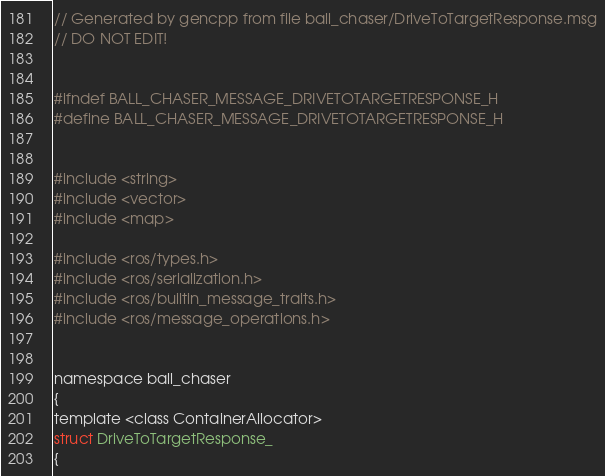<code> <loc_0><loc_0><loc_500><loc_500><_C_>// Generated by gencpp from file ball_chaser/DriveToTargetResponse.msg
// DO NOT EDIT!


#ifndef BALL_CHASER_MESSAGE_DRIVETOTARGETRESPONSE_H
#define BALL_CHASER_MESSAGE_DRIVETOTARGETRESPONSE_H


#include <string>
#include <vector>
#include <map>

#include <ros/types.h>
#include <ros/serialization.h>
#include <ros/builtin_message_traits.h>
#include <ros/message_operations.h>


namespace ball_chaser
{
template <class ContainerAllocator>
struct DriveToTargetResponse_
{</code> 